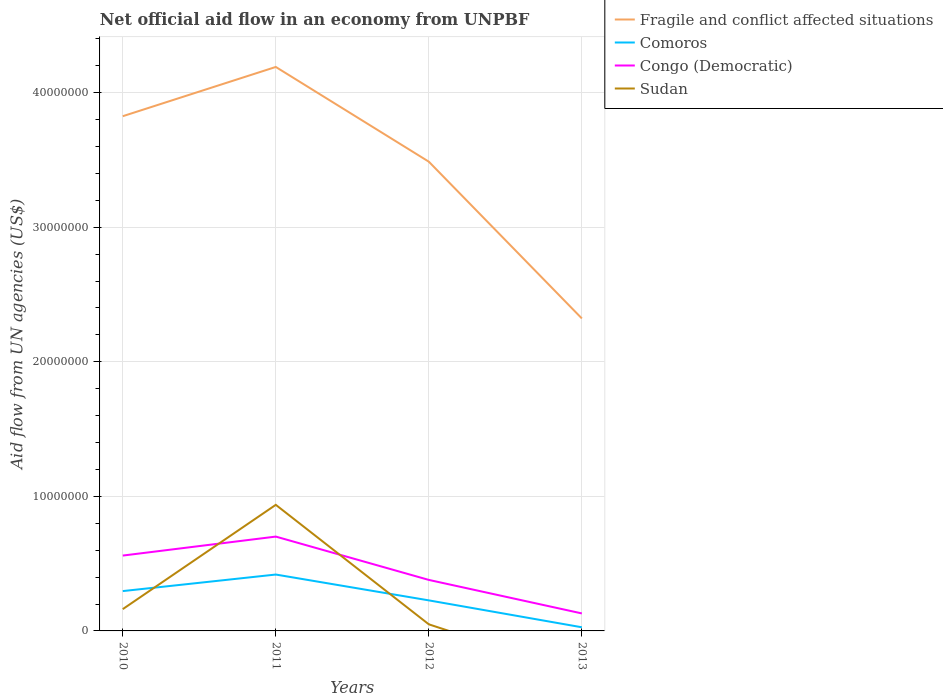Is the number of lines equal to the number of legend labels?
Provide a succinct answer. No. What is the total net official aid flow in Fragile and conflict affected situations in the graph?
Your answer should be compact. 7.04e+06. What is the difference between the highest and the second highest net official aid flow in Fragile and conflict affected situations?
Offer a terse response. 1.87e+07. Is the net official aid flow in Comoros strictly greater than the net official aid flow in Fragile and conflict affected situations over the years?
Make the answer very short. Yes. How many years are there in the graph?
Make the answer very short. 4. Where does the legend appear in the graph?
Provide a succinct answer. Top right. What is the title of the graph?
Offer a very short reply. Net official aid flow in an economy from UNPBF. Does "Slovenia" appear as one of the legend labels in the graph?
Your answer should be very brief. No. What is the label or title of the X-axis?
Your answer should be very brief. Years. What is the label or title of the Y-axis?
Give a very brief answer. Aid flow from UN agencies (US$). What is the Aid flow from UN agencies (US$) in Fragile and conflict affected situations in 2010?
Your answer should be very brief. 3.82e+07. What is the Aid flow from UN agencies (US$) of Comoros in 2010?
Give a very brief answer. 2.96e+06. What is the Aid flow from UN agencies (US$) in Congo (Democratic) in 2010?
Your answer should be compact. 5.60e+06. What is the Aid flow from UN agencies (US$) of Sudan in 2010?
Your response must be concise. 1.62e+06. What is the Aid flow from UN agencies (US$) of Fragile and conflict affected situations in 2011?
Offer a terse response. 4.19e+07. What is the Aid flow from UN agencies (US$) in Comoros in 2011?
Provide a short and direct response. 4.19e+06. What is the Aid flow from UN agencies (US$) in Congo (Democratic) in 2011?
Offer a very short reply. 7.01e+06. What is the Aid flow from UN agencies (US$) in Sudan in 2011?
Provide a short and direct response. 9.37e+06. What is the Aid flow from UN agencies (US$) of Fragile and conflict affected situations in 2012?
Ensure brevity in your answer.  3.49e+07. What is the Aid flow from UN agencies (US$) of Comoros in 2012?
Offer a terse response. 2.27e+06. What is the Aid flow from UN agencies (US$) in Congo (Democratic) in 2012?
Provide a succinct answer. 3.79e+06. What is the Aid flow from UN agencies (US$) in Fragile and conflict affected situations in 2013?
Make the answer very short. 2.32e+07. What is the Aid flow from UN agencies (US$) of Congo (Democratic) in 2013?
Offer a very short reply. 1.30e+06. What is the Aid flow from UN agencies (US$) in Sudan in 2013?
Offer a very short reply. 0. Across all years, what is the maximum Aid flow from UN agencies (US$) of Fragile and conflict affected situations?
Provide a succinct answer. 4.19e+07. Across all years, what is the maximum Aid flow from UN agencies (US$) in Comoros?
Provide a short and direct response. 4.19e+06. Across all years, what is the maximum Aid flow from UN agencies (US$) of Congo (Democratic)?
Your response must be concise. 7.01e+06. Across all years, what is the maximum Aid flow from UN agencies (US$) in Sudan?
Give a very brief answer. 9.37e+06. Across all years, what is the minimum Aid flow from UN agencies (US$) in Fragile and conflict affected situations?
Make the answer very short. 2.32e+07. Across all years, what is the minimum Aid flow from UN agencies (US$) in Congo (Democratic)?
Provide a short and direct response. 1.30e+06. Across all years, what is the minimum Aid flow from UN agencies (US$) in Sudan?
Your response must be concise. 0. What is the total Aid flow from UN agencies (US$) in Fragile and conflict affected situations in the graph?
Keep it short and to the point. 1.38e+08. What is the total Aid flow from UN agencies (US$) in Comoros in the graph?
Offer a terse response. 9.69e+06. What is the total Aid flow from UN agencies (US$) of Congo (Democratic) in the graph?
Give a very brief answer. 1.77e+07. What is the total Aid flow from UN agencies (US$) of Sudan in the graph?
Make the answer very short. 1.15e+07. What is the difference between the Aid flow from UN agencies (US$) in Fragile and conflict affected situations in 2010 and that in 2011?
Keep it short and to the point. -3.66e+06. What is the difference between the Aid flow from UN agencies (US$) in Comoros in 2010 and that in 2011?
Make the answer very short. -1.23e+06. What is the difference between the Aid flow from UN agencies (US$) in Congo (Democratic) in 2010 and that in 2011?
Provide a short and direct response. -1.41e+06. What is the difference between the Aid flow from UN agencies (US$) in Sudan in 2010 and that in 2011?
Offer a very short reply. -7.75e+06. What is the difference between the Aid flow from UN agencies (US$) of Fragile and conflict affected situations in 2010 and that in 2012?
Provide a short and direct response. 3.38e+06. What is the difference between the Aid flow from UN agencies (US$) of Comoros in 2010 and that in 2012?
Give a very brief answer. 6.90e+05. What is the difference between the Aid flow from UN agencies (US$) in Congo (Democratic) in 2010 and that in 2012?
Ensure brevity in your answer.  1.81e+06. What is the difference between the Aid flow from UN agencies (US$) in Sudan in 2010 and that in 2012?
Make the answer very short. 1.13e+06. What is the difference between the Aid flow from UN agencies (US$) of Fragile and conflict affected situations in 2010 and that in 2013?
Keep it short and to the point. 1.50e+07. What is the difference between the Aid flow from UN agencies (US$) of Comoros in 2010 and that in 2013?
Give a very brief answer. 2.69e+06. What is the difference between the Aid flow from UN agencies (US$) of Congo (Democratic) in 2010 and that in 2013?
Keep it short and to the point. 4.30e+06. What is the difference between the Aid flow from UN agencies (US$) in Fragile and conflict affected situations in 2011 and that in 2012?
Offer a very short reply. 7.04e+06. What is the difference between the Aid flow from UN agencies (US$) in Comoros in 2011 and that in 2012?
Your answer should be compact. 1.92e+06. What is the difference between the Aid flow from UN agencies (US$) in Congo (Democratic) in 2011 and that in 2012?
Provide a short and direct response. 3.22e+06. What is the difference between the Aid flow from UN agencies (US$) in Sudan in 2011 and that in 2012?
Provide a succinct answer. 8.88e+06. What is the difference between the Aid flow from UN agencies (US$) of Fragile and conflict affected situations in 2011 and that in 2013?
Your response must be concise. 1.87e+07. What is the difference between the Aid flow from UN agencies (US$) of Comoros in 2011 and that in 2013?
Your response must be concise. 3.92e+06. What is the difference between the Aid flow from UN agencies (US$) in Congo (Democratic) in 2011 and that in 2013?
Your answer should be compact. 5.71e+06. What is the difference between the Aid flow from UN agencies (US$) in Fragile and conflict affected situations in 2012 and that in 2013?
Offer a terse response. 1.16e+07. What is the difference between the Aid flow from UN agencies (US$) in Congo (Democratic) in 2012 and that in 2013?
Provide a short and direct response. 2.49e+06. What is the difference between the Aid flow from UN agencies (US$) in Fragile and conflict affected situations in 2010 and the Aid flow from UN agencies (US$) in Comoros in 2011?
Your response must be concise. 3.41e+07. What is the difference between the Aid flow from UN agencies (US$) in Fragile and conflict affected situations in 2010 and the Aid flow from UN agencies (US$) in Congo (Democratic) in 2011?
Provide a short and direct response. 3.12e+07. What is the difference between the Aid flow from UN agencies (US$) in Fragile and conflict affected situations in 2010 and the Aid flow from UN agencies (US$) in Sudan in 2011?
Give a very brief answer. 2.89e+07. What is the difference between the Aid flow from UN agencies (US$) in Comoros in 2010 and the Aid flow from UN agencies (US$) in Congo (Democratic) in 2011?
Offer a very short reply. -4.05e+06. What is the difference between the Aid flow from UN agencies (US$) of Comoros in 2010 and the Aid flow from UN agencies (US$) of Sudan in 2011?
Your answer should be very brief. -6.41e+06. What is the difference between the Aid flow from UN agencies (US$) of Congo (Democratic) in 2010 and the Aid flow from UN agencies (US$) of Sudan in 2011?
Ensure brevity in your answer.  -3.77e+06. What is the difference between the Aid flow from UN agencies (US$) of Fragile and conflict affected situations in 2010 and the Aid flow from UN agencies (US$) of Comoros in 2012?
Your answer should be very brief. 3.60e+07. What is the difference between the Aid flow from UN agencies (US$) of Fragile and conflict affected situations in 2010 and the Aid flow from UN agencies (US$) of Congo (Democratic) in 2012?
Your answer should be compact. 3.45e+07. What is the difference between the Aid flow from UN agencies (US$) of Fragile and conflict affected situations in 2010 and the Aid flow from UN agencies (US$) of Sudan in 2012?
Your answer should be compact. 3.78e+07. What is the difference between the Aid flow from UN agencies (US$) in Comoros in 2010 and the Aid flow from UN agencies (US$) in Congo (Democratic) in 2012?
Make the answer very short. -8.30e+05. What is the difference between the Aid flow from UN agencies (US$) of Comoros in 2010 and the Aid flow from UN agencies (US$) of Sudan in 2012?
Your response must be concise. 2.47e+06. What is the difference between the Aid flow from UN agencies (US$) in Congo (Democratic) in 2010 and the Aid flow from UN agencies (US$) in Sudan in 2012?
Give a very brief answer. 5.11e+06. What is the difference between the Aid flow from UN agencies (US$) of Fragile and conflict affected situations in 2010 and the Aid flow from UN agencies (US$) of Comoros in 2013?
Your response must be concise. 3.80e+07. What is the difference between the Aid flow from UN agencies (US$) in Fragile and conflict affected situations in 2010 and the Aid flow from UN agencies (US$) in Congo (Democratic) in 2013?
Ensure brevity in your answer.  3.70e+07. What is the difference between the Aid flow from UN agencies (US$) in Comoros in 2010 and the Aid flow from UN agencies (US$) in Congo (Democratic) in 2013?
Keep it short and to the point. 1.66e+06. What is the difference between the Aid flow from UN agencies (US$) of Fragile and conflict affected situations in 2011 and the Aid flow from UN agencies (US$) of Comoros in 2012?
Keep it short and to the point. 3.96e+07. What is the difference between the Aid flow from UN agencies (US$) of Fragile and conflict affected situations in 2011 and the Aid flow from UN agencies (US$) of Congo (Democratic) in 2012?
Give a very brief answer. 3.81e+07. What is the difference between the Aid flow from UN agencies (US$) in Fragile and conflict affected situations in 2011 and the Aid flow from UN agencies (US$) in Sudan in 2012?
Provide a short and direct response. 4.14e+07. What is the difference between the Aid flow from UN agencies (US$) of Comoros in 2011 and the Aid flow from UN agencies (US$) of Congo (Democratic) in 2012?
Your answer should be compact. 4.00e+05. What is the difference between the Aid flow from UN agencies (US$) of Comoros in 2011 and the Aid flow from UN agencies (US$) of Sudan in 2012?
Offer a terse response. 3.70e+06. What is the difference between the Aid flow from UN agencies (US$) in Congo (Democratic) in 2011 and the Aid flow from UN agencies (US$) in Sudan in 2012?
Give a very brief answer. 6.52e+06. What is the difference between the Aid flow from UN agencies (US$) in Fragile and conflict affected situations in 2011 and the Aid flow from UN agencies (US$) in Comoros in 2013?
Offer a terse response. 4.16e+07. What is the difference between the Aid flow from UN agencies (US$) of Fragile and conflict affected situations in 2011 and the Aid flow from UN agencies (US$) of Congo (Democratic) in 2013?
Your answer should be compact. 4.06e+07. What is the difference between the Aid flow from UN agencies (US$) in Comoros in 2011 and the Aid flow from UN agencies (US$) in Congo (Democratic) in 2013?
Your answer should be very brief. 2.89e+06. What is the difference between the Aid flow from UN agencies (US$) of Fragile and conflict affected situations in 2012 and the Aid flow from UN agencies (US$) of Comoros in 2013?
Ensure brevity in your answer.  3.46e+07. What is the difference between the Aid flow from UN agencies (US$) in Fragile and conflict affected situations in 2012 and the Aid flow from UN agencies (US$) in Congo (Democratic) in 2013?
Offer a very short reply. 3.36e+07. What is the difference between the Aid flow from UN agencies (US$) of Comoros in 2012 and the Aid flow from UN agencies (US$) of Congo (Democratic) in 2013?
Offer a very short reply. 9.70e+05. What is the average Aid flow from UN agencies (US$) of Fragile and conflict affected situations per year?
Your response must be concise. 3.46e+07. What is the average Aid flow from UN agencies (US$) of Comoros per year?
Make the answer very short. 2.42e+06. What is the average Aid flow from UN agencies (US$) in Congo (Democratic) per year?
Offer a very short reply. 4.42e+06. What is the average Aid flow from UN agencies (US$) of Sudan per year?
Your response must be concise. 2.87e+06. In the year 2010, what is the difference between the Aid flow from UN agencies (US$) in Fragile and conflict affected situations and Aid flow from UN agencies (US$) in Comoros?
Make the answer very short. 3.53e+07. In the year 2010, what is the difference between the Aid flow from UN agencies (US$) in Fragile and conflict affected situations and Aid flow from UN agencies (US$) in Congo (Democratic)?
Your answer should be compact. 3.26e+07. In the year 2010, what is the difference between the Aid flow from UN agencies (US$) of Fragile and conflict affected situations and Aid flow from UN agencies (US$) of Sudan?
Give a very brief answer. 3.66e+07. In the year 2010, what is the difference between the Aid flow from UN agencies (US$) in Comoros and Aid flow from UN agencies (US$) in Congo (Democratic)?
Make the answer very short. -2.64e+06. In the year 2010, what is the difference between the Aid flow from UN agencies (US$) in Comoros and Aid flow from UN agencies (US$) in Sudan?
Your response must be concise. 1.34e+06. In the year 2010, what is the difference between the Aid flow from UN agencies (US$) of Congo (Democratic) and Aid flow from UN agencies (US$) of Sudan?
Give a very brief answer. 3.98e+06. In the year 2011, what is the difference between the Aid flow from UN agencies (US$) in Fragile and conflict affected situations and Aid flow from UN agencies (US$) in Comoros?
Provide a succinct answer. 3.77e+07. In the year 2011, what is the difference between the Aid flow from UN agencies (US$) in Fragile and conflict affected situations and Aid flow from UN agencies (US$) in Congo (Democratic)?
Make the answer very short. 3.49e+07. In the year 2011, what is the difference between the Aid flow from UN agencies (US$) of Fragile and conflict affected situations and Aid flow from UN agencies (US$) of Sudan?
Your answer should be compact. 3.25e+07. In the year 2011, what is the difference between the Aid flow from UN agencies (US$) in Comoros and Aid flow from UN agencies (US$) in Congo (Democratic)?
Your response must be concise. -2.82e+06. In the year 2011, what is the difference between the Aid flow from UN agencies (US$) in Comoros and Aid flow from UN agencies (US$) in Sudan?
Your answer should be very brief. -5.18e+06. In the year 2011, what is the difference between the Aid flow from UN agencies (US$) of Congo (Democratic) and Aid flow from UN agencies (US$) of Sudan?
Your answer should be very brief. -2.36e+06. In the year 2012, what is the difference between the Aid flow from UN agencies (US$) in Fragile and conflict affected situations and Aid flow from UN agencies (US$) in Comoros?
Keep it short and to the point. 3.26e+07. In the year 2012, what is the difference between the Aid flow from UN agencies (US$) of Fragile and conflict affected situations and Aid flow from UN agencies (US$) of Congo (Democratic)?
Your answer should be very brief. 3.11e+07. In the year 2012, what is the difference between the Aid flow from UN agencies (US$) in Fragile and conflict affected situations and Aid flow from UN agencies (US$) in Sudan?
Your answer should be very brief. 3.44e+07. In the year 2012, what is the difference between the Aid flow from UN agencies (US$) in Comoros and Aid flow from UN agencies (US$) in Congo (Democratic)?
Provide a short and direct response. -1.52e+06. In the year 2012, what is the difference between the Aid flow from UN agencies (US$) in Comoros and Aid flow from UN agencies (US$) in Sudan?
Provide a succinct answer. 1.78e+06. In the year 2012, what is the difference between the Aid flow from UN agencies (US$) of Congo (Democratic) and Aid flow from UN agencies (US$) of Sudan?
Provide a short and direct response. 3.30e+06. In the year 2013, what is the difference between the Aid flow from UN agencies (US$) in Fragile and conflict affected situations and Aid flow from UN agencies (US$) in Comoros?
Offer a terse response. 2.30e+07. In the year 2013, what is the difference between the Aid flow from UN agencies (US$) of Fragile and conflict affected situations and Aid flow from UN agencies (US$) of Congo (Democratic)?
Give a very brief answer. 2.19e+07. In the year 2013, what is the difference between the Aid flow from UN agencies (US$) in Comoros and Aid flow from UN agencies (US$) in Congo (Democratic)?
Make the answer very short. -1.03e+06. What is the ratio of the Aid flow from UN agencies (US$) of Fragile and conflict affected situations in 2010 to that in 2011?
Offer a very short reply. 0.91. What is the ratio of the Aid flow from UN agencies (US$) in Comoros in 2010 to that in 2011?
Make the answer very short. 0.71. What is the ratio of the Aid flow from UN agencies (US$) in Congo (Democratic) in 2010 to that in 2011?
Your answer should be very brief. 0.8. What is the ratio of the Aid flow from UN agencies (US$) of Sudan in 2010 to that in 2011?
Your answer should be very brief. 0.17. What is the ratio of the Aid flow from UN agencies (US$) in Fragile and conflict affected situations in 2010 to that in 2012?
Give a very brief answer. 1.1. What is the ratio of the Aid flow from UN agencies (US$) of Comoros in 2010 to that in 2012?
Make the answer very short. 1.3. What is the ratio of the Aid flow from UN agencies (US$) of Congo (Democratic) in 2010 to that in 2012?
Keep it short and to the point. 1.48. What is the ratio of the Aid flow from UN agencies (US$) of Sudan in 2010 to that in 2012?
Offer a very short reply. 3.31. What is the ratio of the Aid flow from UN agencies (US$) of Fragile and conflict affected situations in 2010 to that in 2013?
Ensure brevity in your answer.  1.65. What is the ratio of the Aid flow from UN agencies (US$) of Comoros in 2010 to that in 2013?
Provide a succinct answer. 10.96. What is the ratio of the Aid flow from UN agencies (US$) in Congo (Democratic) in 2010 to that in 2013?
Provide a succinct answer. 4.31. What is the ratio of the Aid flow from UN agencies (US$) of Fragile and conflict affected situations in 2011 to that in 2012?
Offer a terse response. 1.2. What is the ratio of the Aid flow from UN agencies (US$) of Comoros in 2011 to that in 2012?
Ensure brevity in your answer.  1.85. What is the ratio of the Aid flow from UN agencies (US$) of Congo (Democratic) in 2011 to that in 2012?
Your answer should be compact. 1.85. What is the ratio of the Aid flow from UN agencies (US$) of Sudan in 2011 to that in 2012?
Your response must be concise. 19.12. What is the ratio of the Aid flow from UN agencies (US$) in Fragile and conflict affected situations in 2011 to that in 2013?
Offer a terse response. 1.8. What is the ratio of the Aid flow from UN agencies (US$) in Comoros in 2011 to that in 2013?
Your answer should be compact. 15.52. What is the ratio of the Aid flow from UN agencies (US$) of Congo (Democratic) in 2011 to that in 2013?
Your response must be concise. 5.39. What is the ratio of the Aid flow from UN agencies (US$) of Fragile and conflict affected situations in 2012 to that in 2013?
Make the answer very short. 1.5. What is the ratio of the Aid flow from UN agencies (US$) of Comoros in 2012 to that in 2013?
Provide a succinct answer. 8.41. What is the ratio of the Aid flow from UN agencies (US$) in Congo (Democratic) in 2012 to that in 2013?
Your answer should be compact. 2.92. What is the difference between the highest and the second highest Aid flow from UN agencies (US$) of Fragile and conflict affected situations?
Your answer should be very brief. 3.66e+06. What is the difference between the highest and the second highest Aid flow from UN agencies (US$) in Comoros?
Provide a succinct answer. 1.23e+06. What is the difference between the highest and the second highest Aid flow from UN agencies (US$) in Congo (Democratic)?
Your response must be concise. 1.41e+06. What is the difference between the highest and the second highest Aid flow from UN agencies (US$) in Sudan?
Offer a terse response. 7.75e+06. What is the difference between the highest and the lowest Aid flow from UN agencies (US$) in Fragile and conflict affected situations?
Your response must be concise. 1.87e+07. What is the difference between the highest and the lowest Aid flow from UN agencies (US$) in Comoros?
Provide a short and direct response. 3.92e+06. What is the difference between the highest and the lowest Aid flow from UN agencies (US$) in Congo (Democratic)?
Give a very brief answer. 5.71e+06. What is the difference between the highest and the lowest Aid flow from UN agencies (US$) in Sudan?
Offer a terse response. 9.37e+06. 